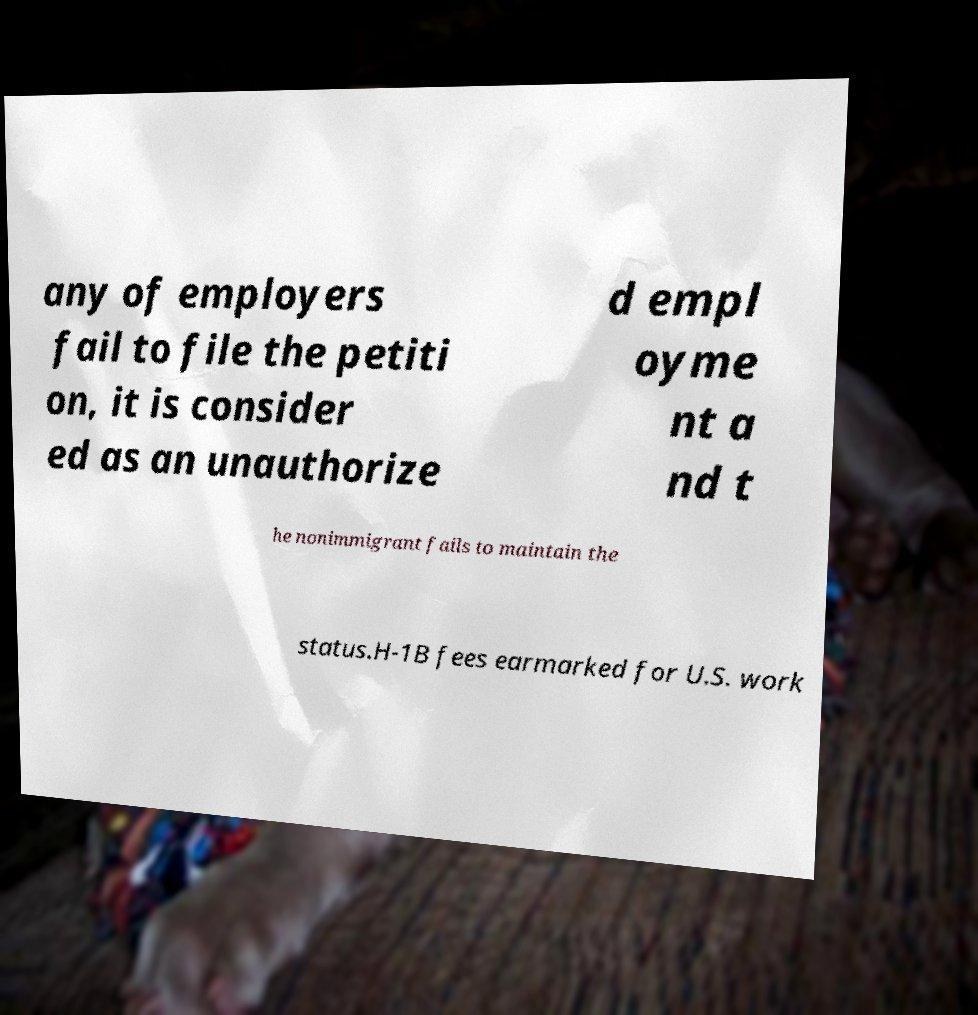I need the written content from this picture converted into text. Can you do that? any of employers fail to file the petiti on, it is consider ed as an unauthorize d empl oyme nt a nd t he nonimmigrant fails to maintain the status.H-1B fees earmarked for U.S. work 